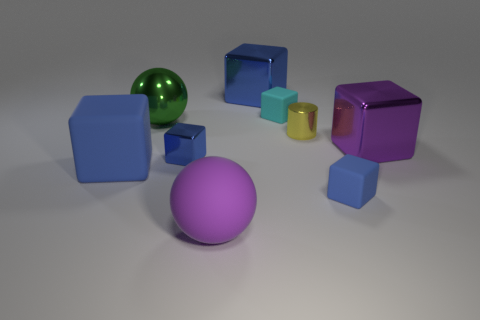What number of cyan objects are metallic spheres or small blocks?
Ensure brevity in your answer.  1. There is a yellow cylinder that is made of the same material as the large green object; what is its size?
Your answer should be very brief. Small. Does the blue object in front of the big blue rubber block have the same material as the big blue cube that is in front of the big green shiny thing?
Your answer should be very brief. Yes. How many spheres are large blue metallic objects or large blue objects?
Provide a succinct answer. 0. What number of yellow cylinders are right of the large thing behind the big ball behind the small blue matte block?
Your response must be concise. 1. There is a large purple object that is the same shape as the tiny blue rubber object; what is its material?
Ensure brevity in your answer.  Metal. There is a large metallic block that is behind the big shiny ball; what is its color?
Give a very brief answer. Blue. Do the big green thing and the large block that is right of the large blue metal thing have the same material?
Give a very brief answer. Yes. What material is the tiny cyan object?
Make the answer very short. Rubber. What is the shape of the big blue thing that is made of the same material as the large green thing?
Offer a very short reply. Cube. 